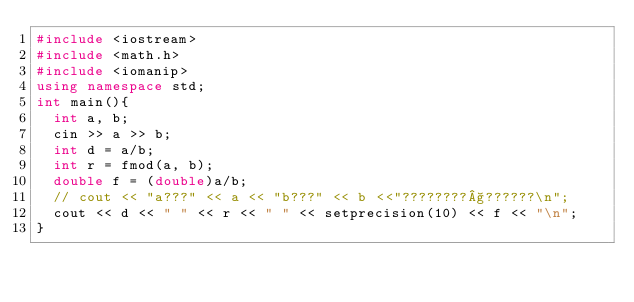<code> <loc_0><loc_0><loc_500><loc_500><_C++_>#include <iostream>
#include <math.h>
#include <iomanip>
using namespace std;
int main(){
  int a, b;
  cin >> a >> b;
  int d = a/b;
  int r = fmod(a, b);
  double f = (double)a/b;
  // cout << "a???" << a << "b???" << b <<"????????§??????\n";
  cout << d << " " << r << " " << setprecision(10) << f << "\n";
}</code> 